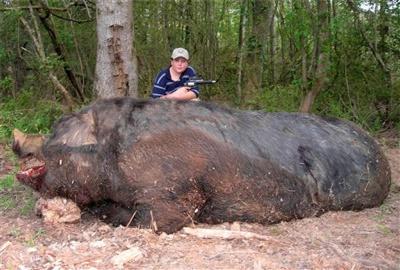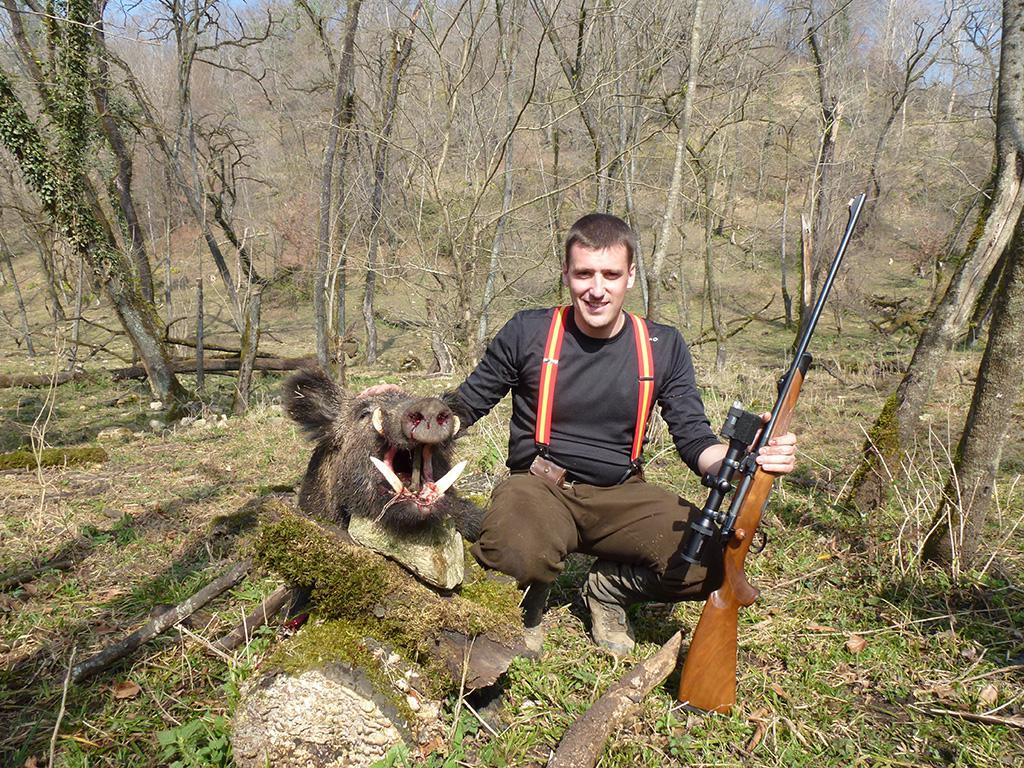The first image is the image on the left, the second image is the image on the right. Analyze the images presented: Is the assertion "The right image contains a hunter posing with a dead boar." valid? Answer yes or no. Yes. The first image is the image on the left, the second image is the image on the right. Considering the images on both sides, is "At least one man is standing behind a dead wild boar holding a gun." valid? Answer yes or no. Yes. 